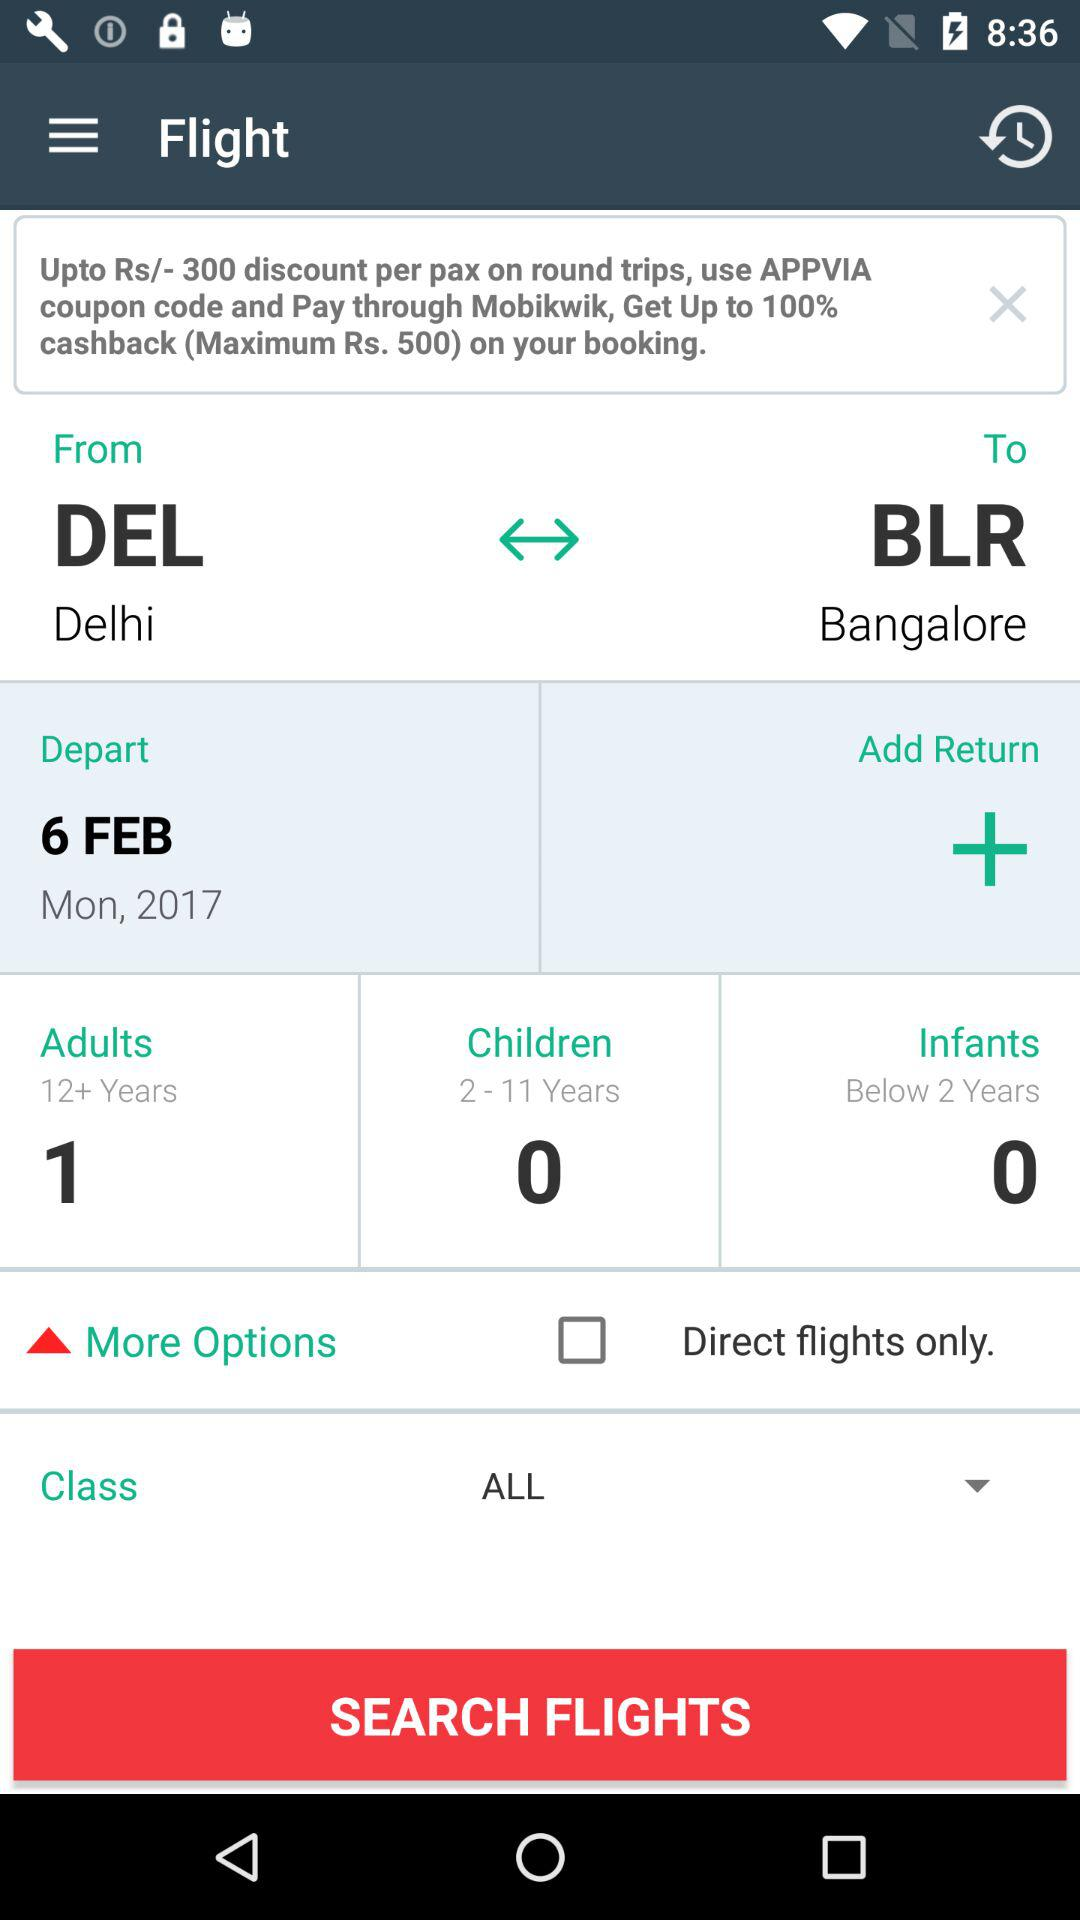How many adults are there in the booking?
Answer the question using a single word or phrase. 1 